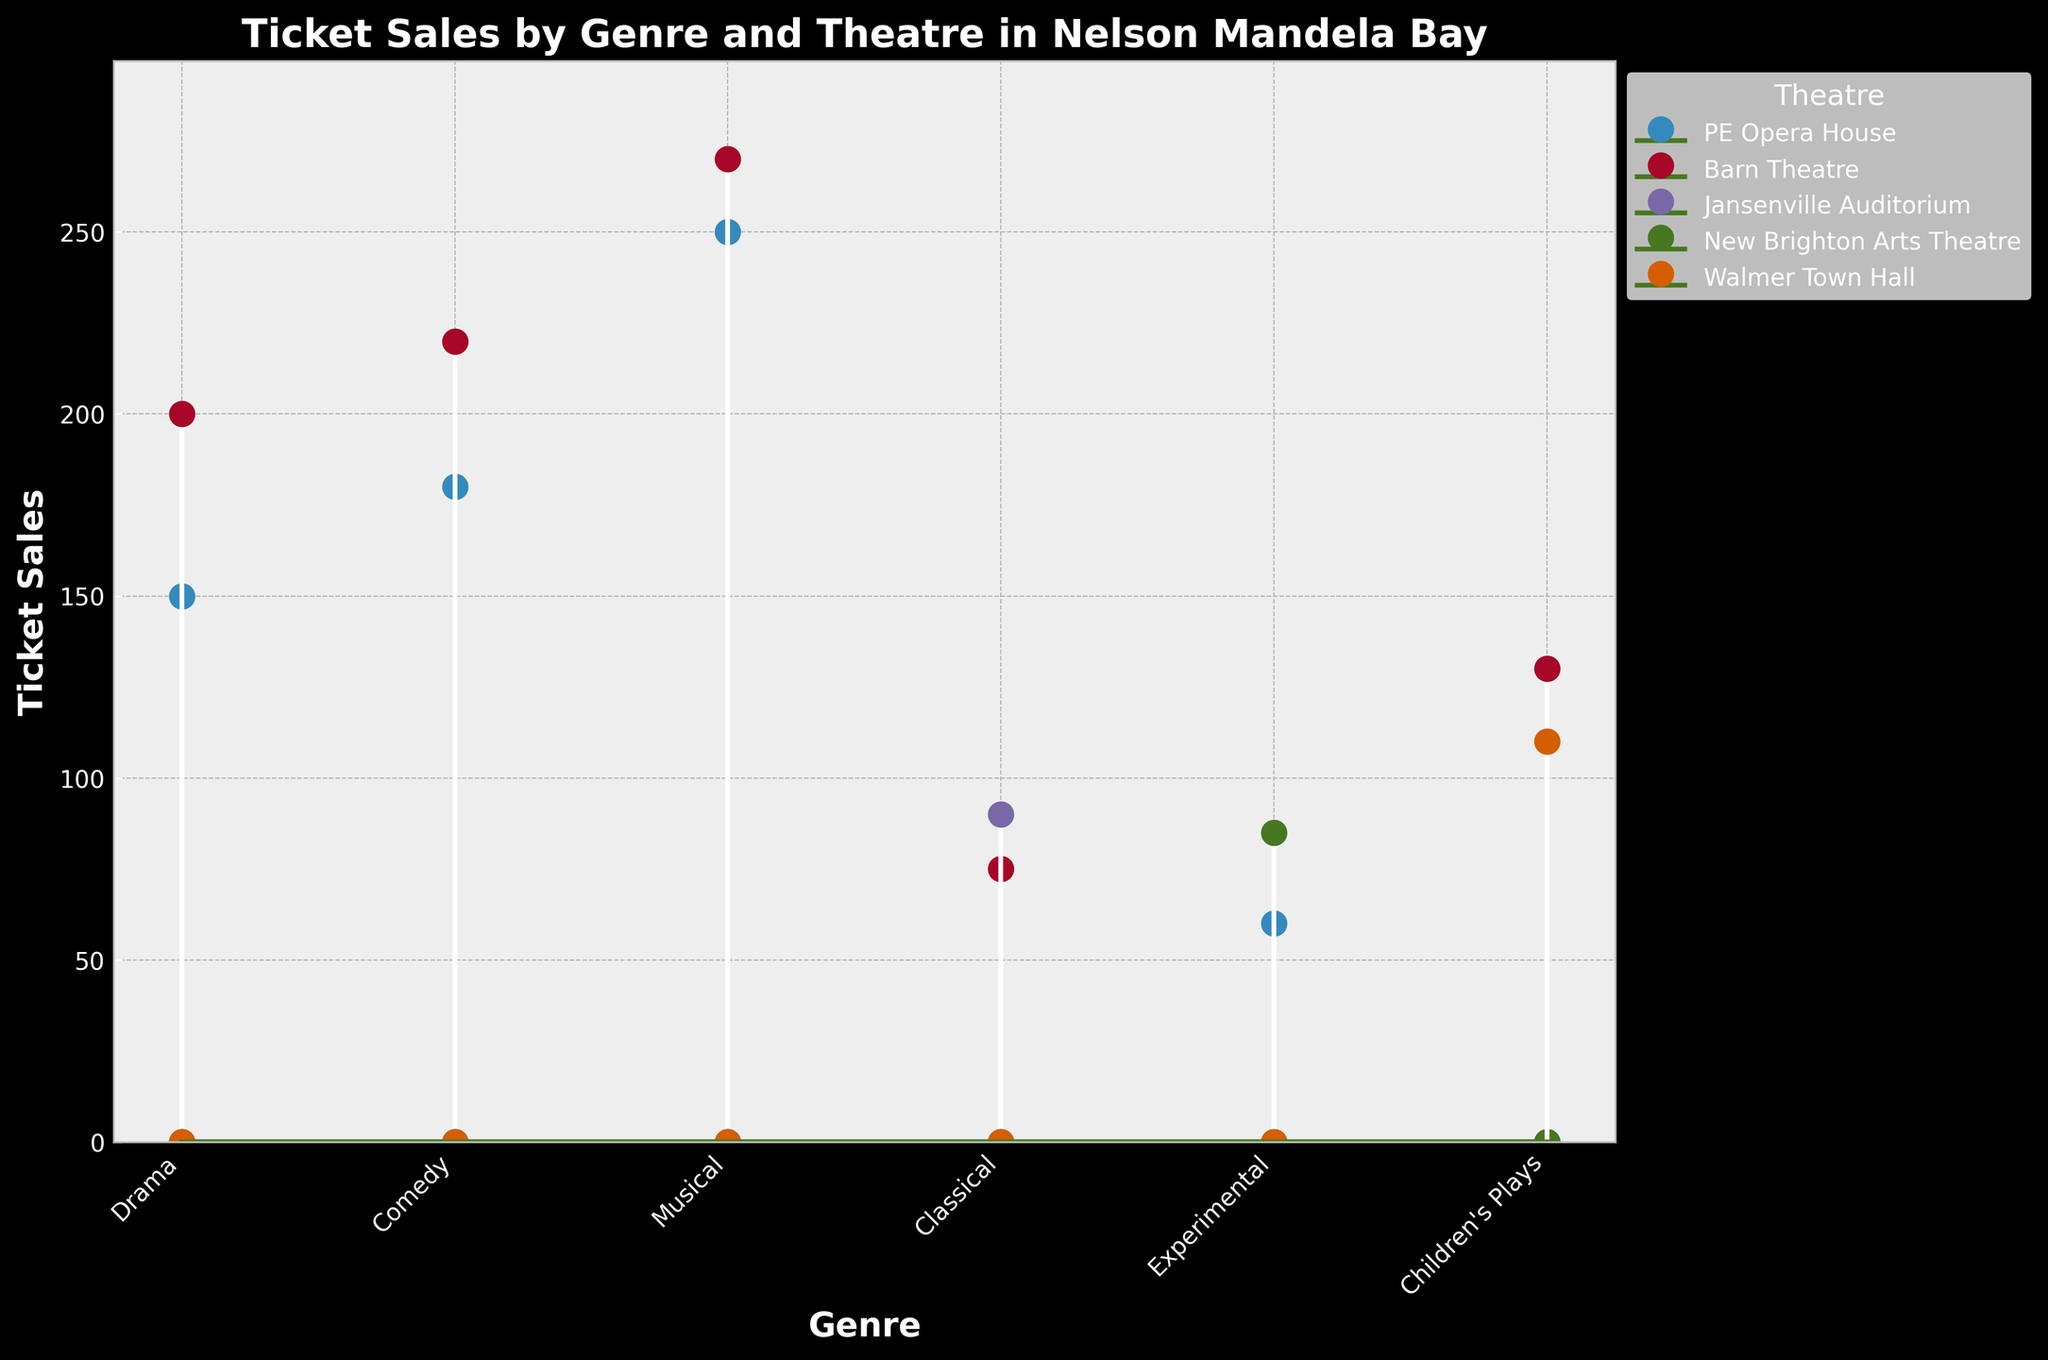What is the title of the figure? The title is typically located at the top of the plot. In this case, the title reads "Ticket Sales by Genre and Theatre in Nelson Mandela Bay".
Answer: Ticket Sales by Genre and Theatre in Nelson Mandela Bay Which theatre has the highest ticket sales for the Musical genre? Look at the data points corresponding to the "Musical" genre and identify which theatre has the highest value. From the plot, the Barn Theatre has 270 ticket sales for the Musical genre, which is the highest.
Answer: Barn Theatre What is the total number of ticket sales for the Drama genre across all theatres? Sum the ticket sales for the Drama genre in both the PE Opera House (150) and Barn Theatre (200). So, the total is 150 + 200.
Answer: 350 Which genre has the least ticket sales in the PE Opera House? Inspect the data points for PE Opera House, and identify the genre corresponding to the lowest point. The Experimental genre has the lowest ticket sales in the PE Opera House with 60 tickets.
Answer: Experimental Compare the ticket sales for Children's Plays between Walmer Town Hall and Barn Theatre. Which one sold more tickets? Observe the "Children's Plays" data points for both Walmer Town Hall and Barn Theatre. Compare the values; Walmer Town Hall has 110 sales, and Barn Theatre has 130 sales. Barn Theatre has more.
Answer: Barn Theatre What is the average ticket sales for the Comedy genre? Sum the ticket sales for the Comedy genre in both PE Opera House (180) and Barn Theatre (220) and divide by the number of theatres (2). So, the average is (180 + 220) / 2.
Answer: 200 Which theatre has more consistent ticket sales across different genres? Examine the variability of ticket sales for each theatre by observing how spread out the data points are for each theatre. PE Opera House shows a wide range, whereas Barn Theatre's ticket sales are more consistent (most values between 130 to 270).
Answer: Barn Theatre How many genres are present in this plot? Count the number of unique genres listed along the x-axis of the plot. There are Drama, Comedy, Musical, Classical, Experimental, and Children's Plays, which totals to 6 genres.
Answer: 6 